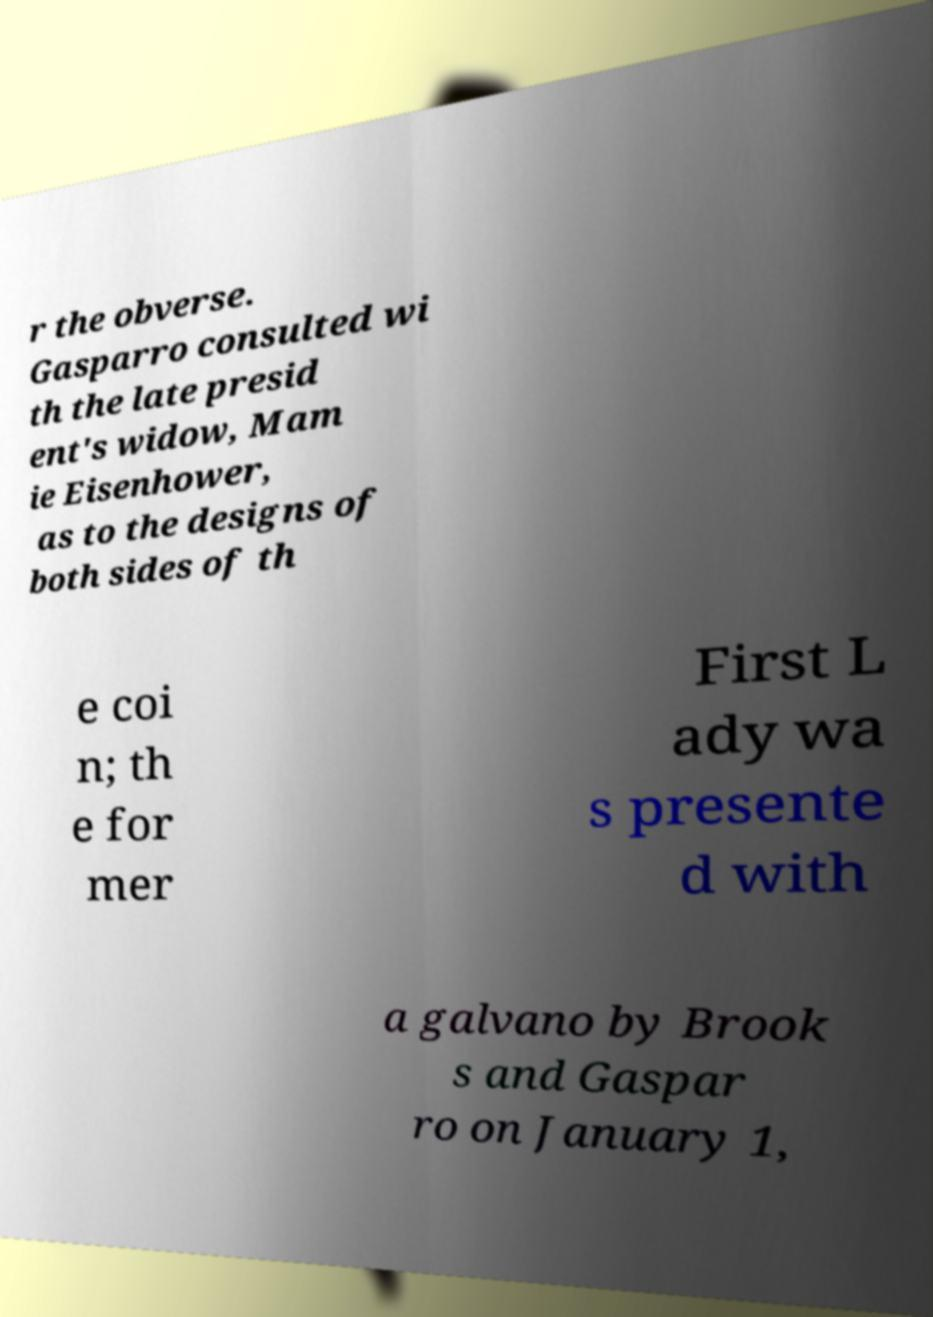Please read and relay the text visible in this image. What does it say? r the obverse. Gasparro consulted wi th the late presid ent's widow, Mam ie Eisenhower, as to the designs of both sides of th e coi n; th e for mer First L ady wa s presente d with a galvano by Brook s and Gaspar ro on January 1, 